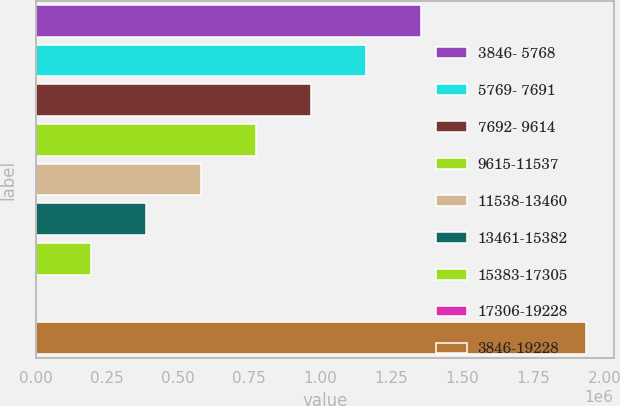Convert chart. <chart><loc_0><loc_0><loc_500><loc_500><bar_chart><fcel>3846- 5768<fcel>5769- 7691<fcel>7692- 9614<fcel>9615-11537<fcel>11538-13460<fcel>13461-15382<fcel>15383-17305<fcel>17306-19228<fcel>3846-19228<nl><fcel>1.35515e+06<fcel>1.16174e+06<fcel>968342<fcel>774940<fcel>581538<fcel>388137<fcel>194735<fcel>1333<fcel>1.93535e+06<nl></chart> 